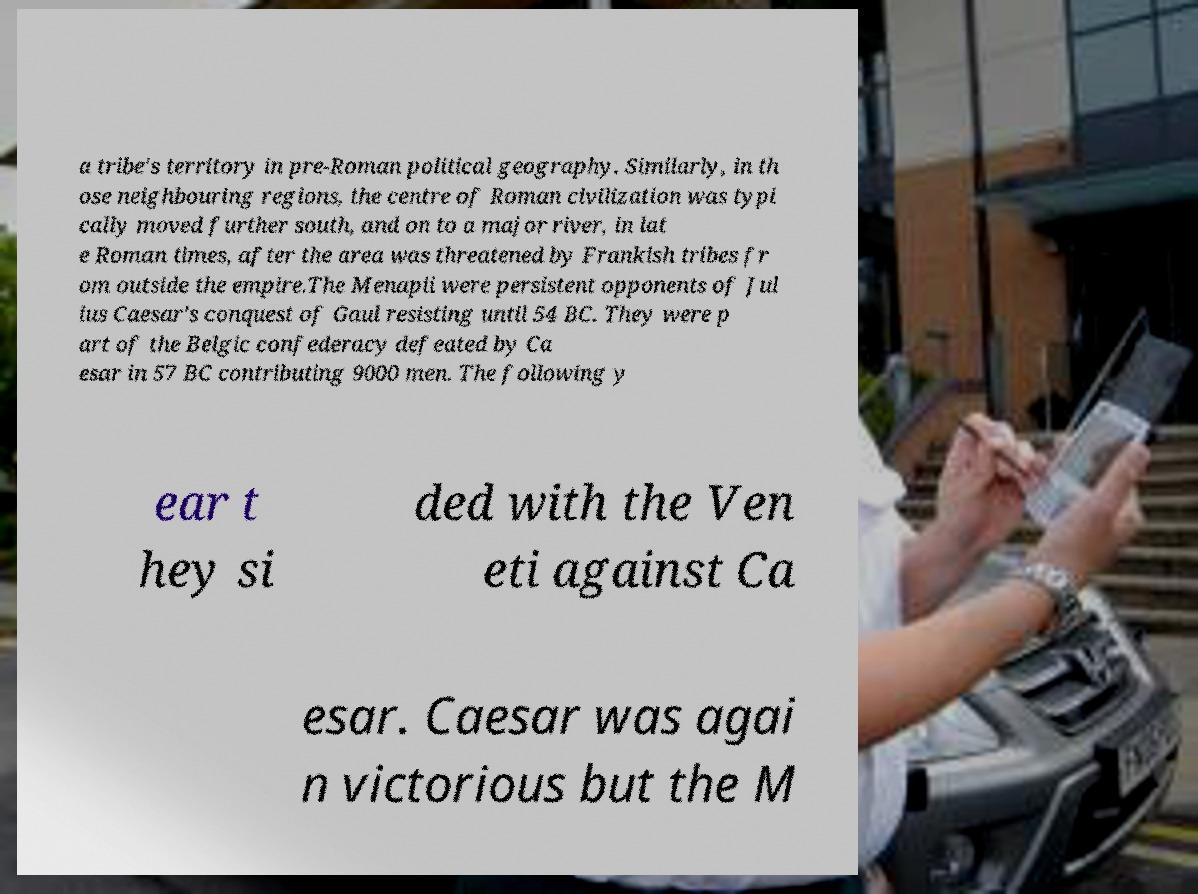Please read and relay the text visible in this image. What does it say? a tribe's territory in pre-Roman political geography. Similarly, in th ose neighbouring regions, the centre of Roman civilization was typi cally moved further south, and on to a major river, in lat e Roman times, after the area was threatened by Frankish tribes fr om outside the empire.The Menapii were persistent opponents of Jul ius Caesar's conquest of Gaul resisting until 54 BC. They were p art of the Belgic confederacy defeated by Ca esar in 57 BC contributing 9000 men. The following y ear t hey si ded with the Ven eti against Ca esar. Caesar was agai n victorious but the M 